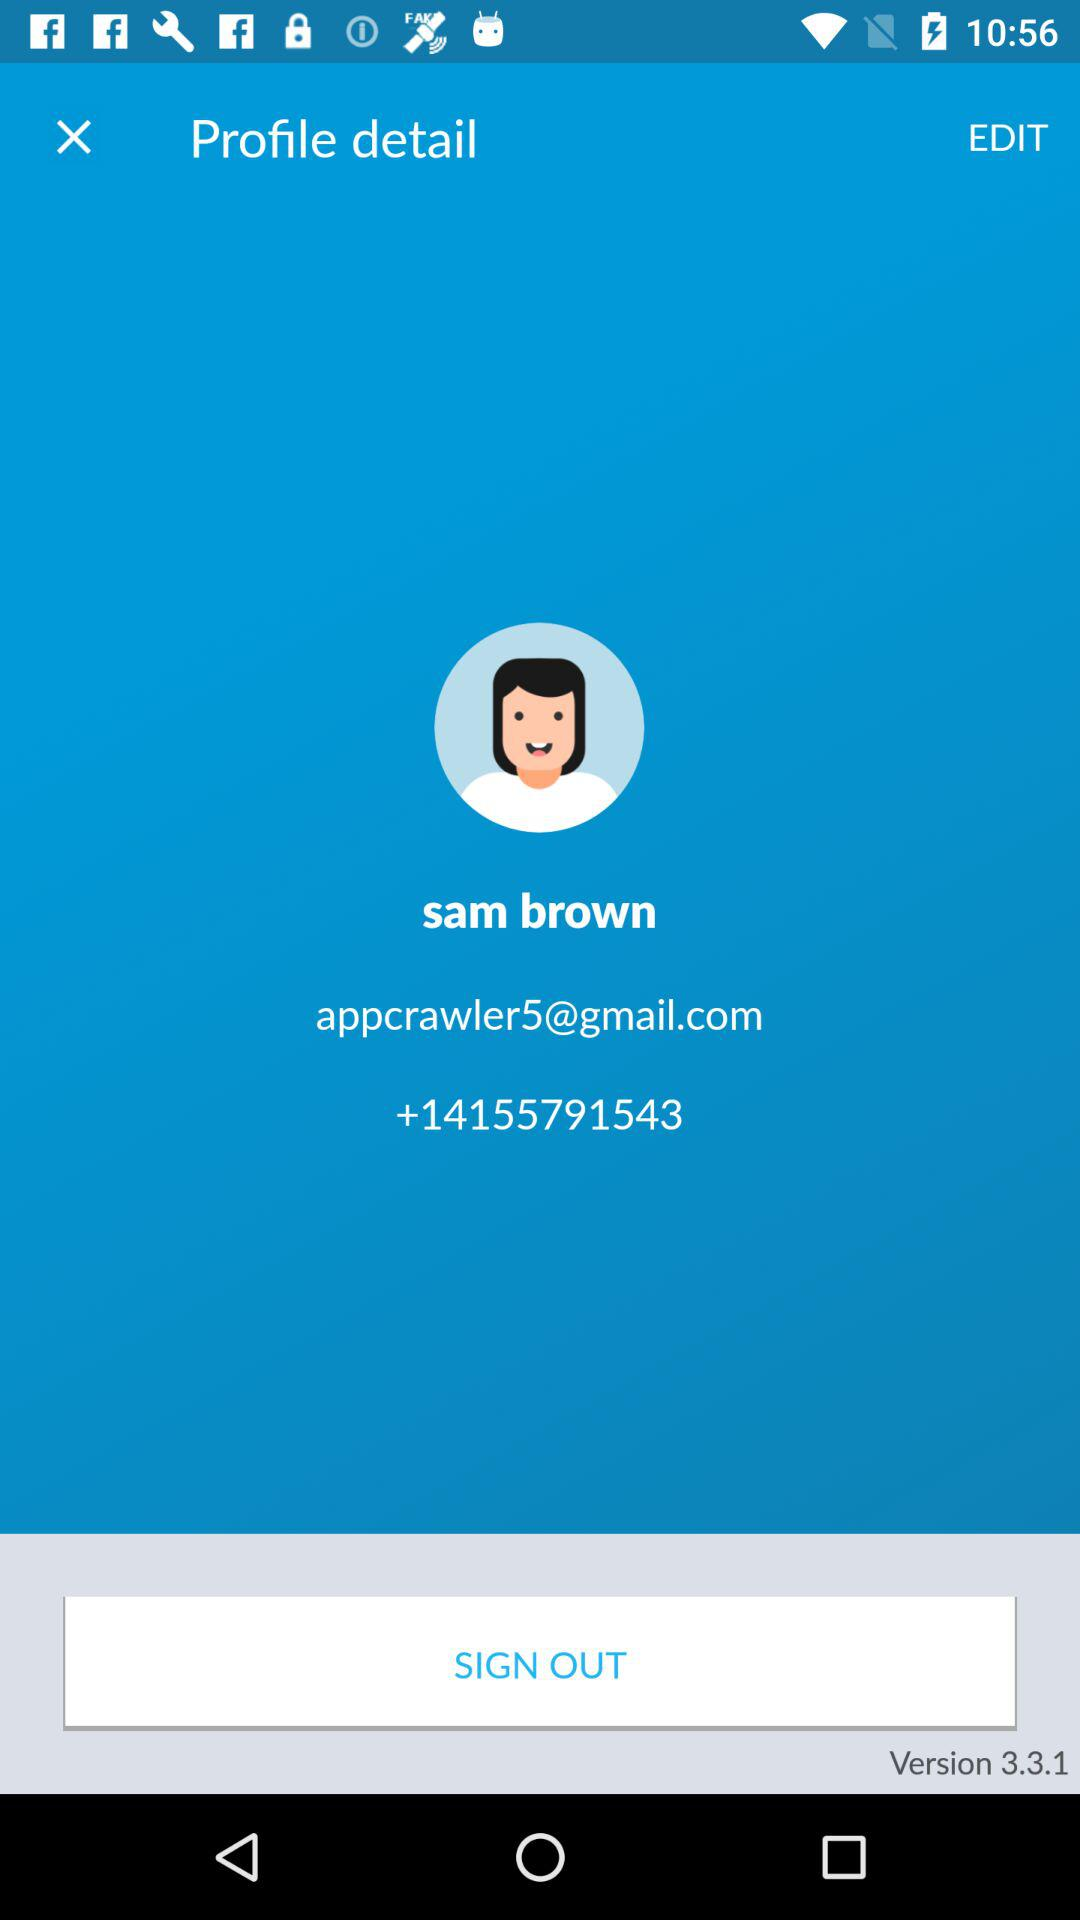How many text fields are there in the profile details section?
Answer the question using a single word or phrase. 3 